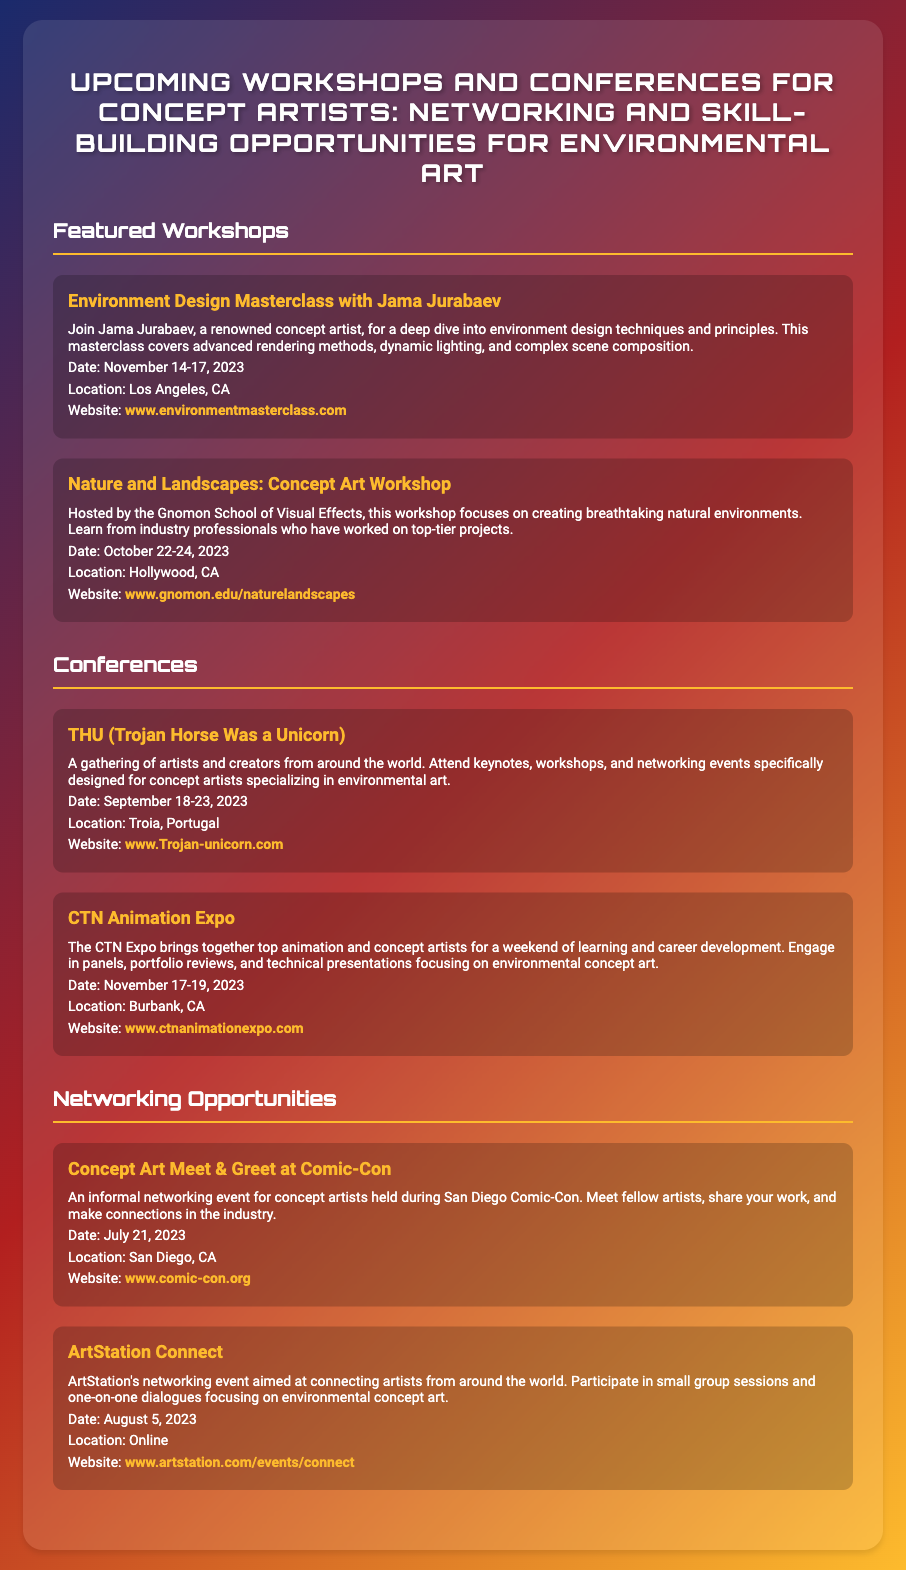What is the title of the first workshop? The title of the first workshop listed in the document is "Environment Design Masterclass with Jama Jurabaev."
Answer: Environment Design Masterclass with Jama Jurabaev What is the date of the CTN Animation Expo? The date of the CTN Animation Expo is mentioned clearly in the document as November 17-19, 2023.
Answer: November 17-19, 2023 Where is the Nature and Landscapes workshop located? The document specifies that the Nature and Landscapes workshop is located in Hollywood, CA.
Answer: Hollywood, CA Which conference is scheduled for September 18-23, 2023? The conference scheduled for September 18-23, 2023, is THU (Trojan Horse Was a Unicorn).
Answer: THU (Trojan Horse Was a Unicorn) What networking event is taking place at Comic-Con? The document states that the networking event taking place at Comic-Con is called "Concept Art Meet & Greet at Comic-Con."
Answer: Concept Art Meet & Greet at Comic-Con How many featured workshops are listed in the document? The document lists two featured workshops for concept artists.
Answer: Two What is the main focus of the Nature and Landscapes workshop? The main focus of the Nature and Landscapes workshop is creating breathtaking natural environments.
Answer: Creating breathtaking natural environments When is the ArtStation Connect event scheduled? The ArtStation Connect event is scheduled for August 5, 2023, as stated in the document.
Answer: August 5, 2023 